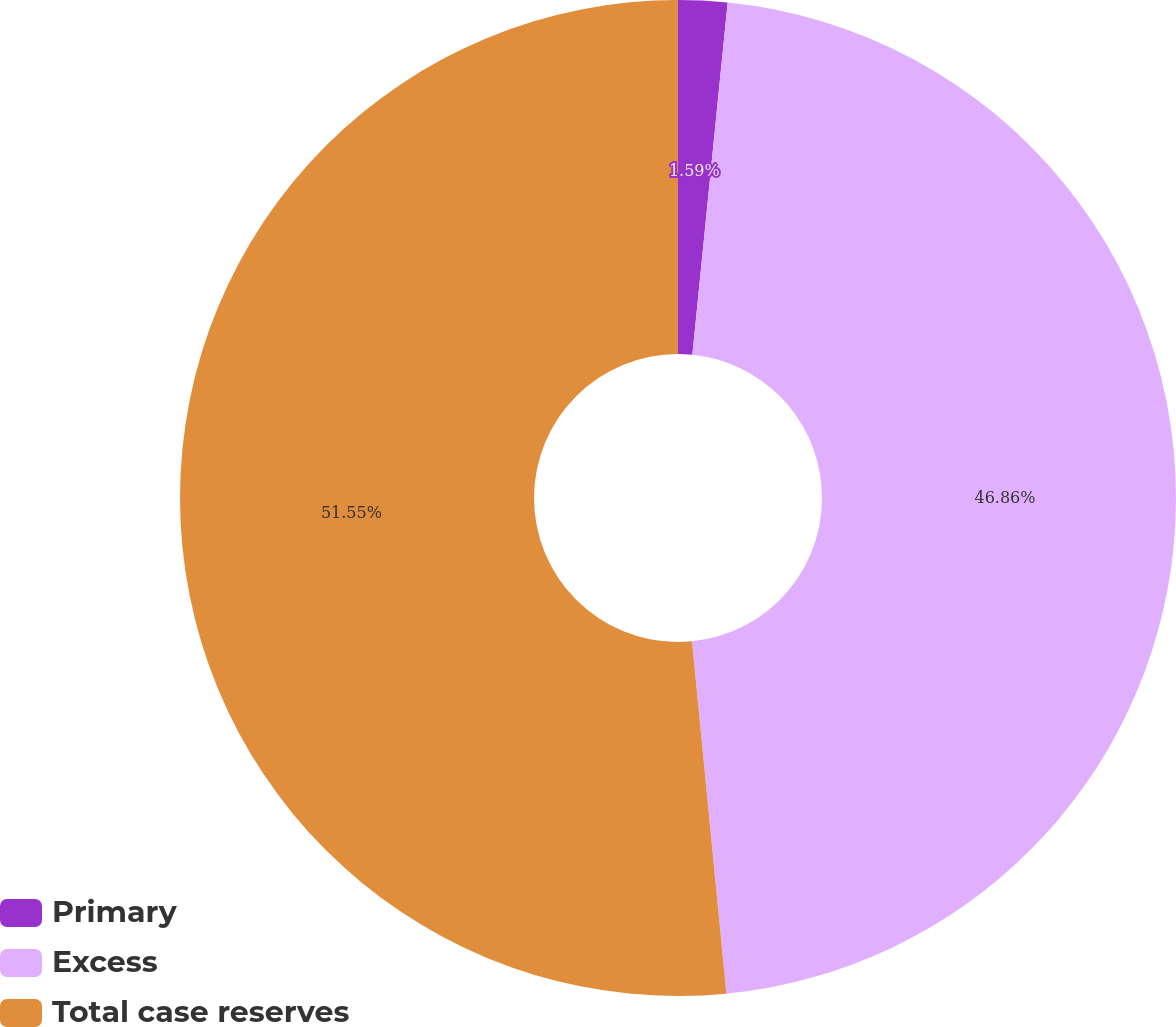Convert chart. <chart><loc_0><loc_0><loc_500><loc_500><pie_chart><fcel>Primary<fcel>Excess<fcel>Total case reserves<nl><fcel>1.59%<fcel>46.86%<fcel>51.55%<nl></chart> 